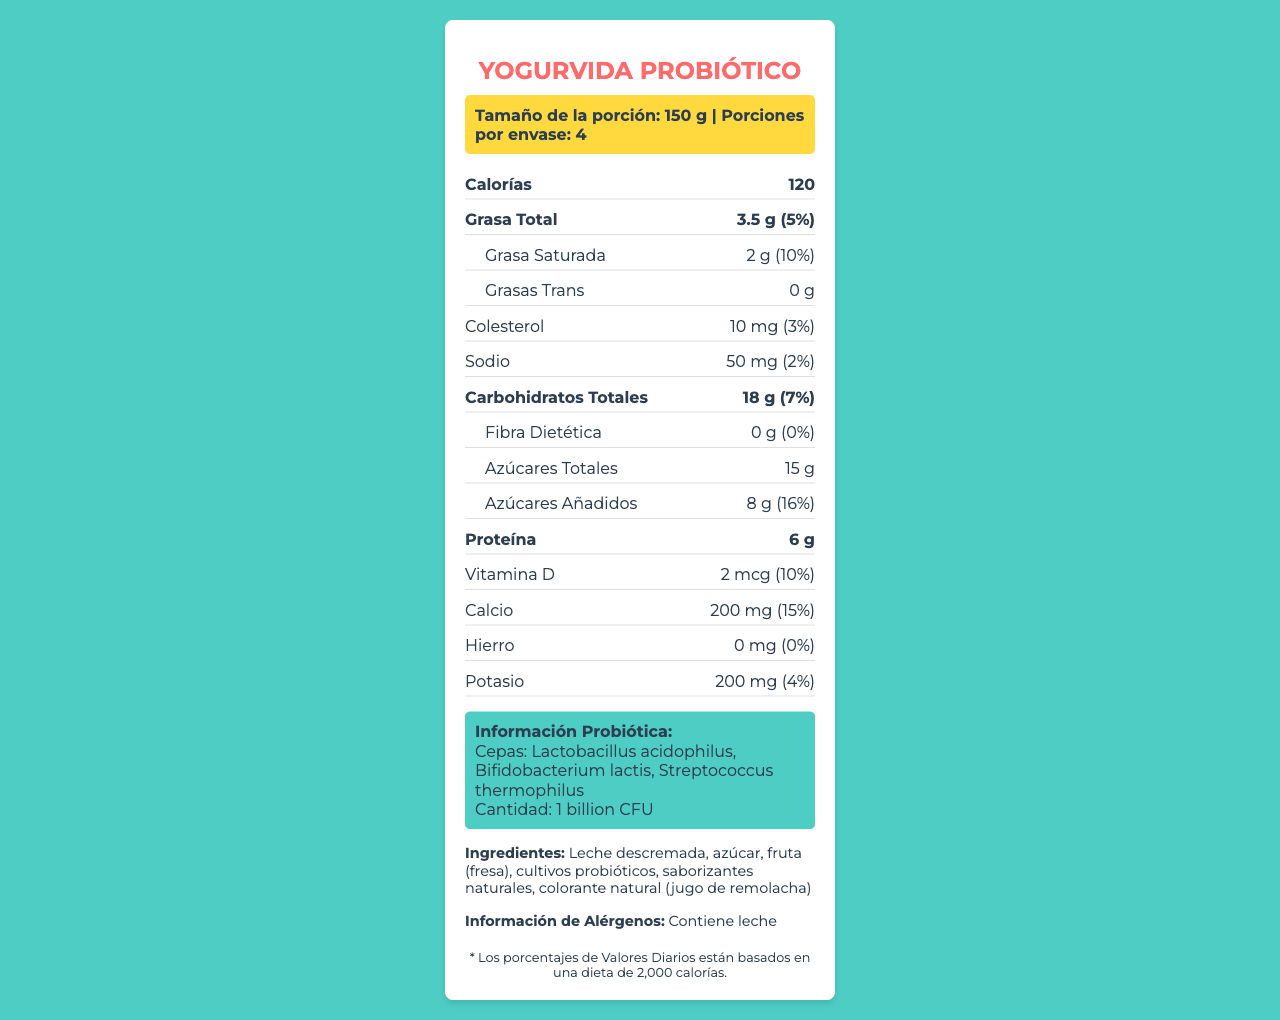¿Cuál es el tamaño de la porción? La información se encuentra en la sección de "Tamaño de la porción".
Answer: 150 g ¿Cuántas porciones hay por envase? La información se encuentra en la sección de "Porciones por envase".
Answer: 4 ¿Cuántas calorías tiene cada porción? La información se encuentra en la sección de "Calorías".
Answer: 120 ¿Qué cantidad de proteínas tiene el yogur? La información se encuentra en la sección de "Proteína".
Answer: 6 g ¿Qué porcentaje del valor diario de calcio proporciona una porción? La información se encuentra en la sección de "Calcio".
Answer: 15% ¿Qué ingredientes contiene el yogur? La información se encuentra en la sección de "Ingredientes".
Answer: Leche descremada, azúcar, fruta (fresa), cultivos probióticos, saborizantes naturales, colorante natural (jugo de remolacha) ¿Cuáles son las cepas probióticas presentes en este yogur? A. Lactobacillus acidophilus y Bifidobacterium breve B. Lactobacillus acidophilus y Streptococcus thermophilus C. Bifidobacterium lactis y Streptococcus thermophilus D. Lactobacillus acidophilus, Bifidobacterium lactis, y Streptococcus thermophilus La información se encuentra en la sección de "Información Probiótica".
Answer: D ¿Qué cantidad de vitamina D proporciona este yogur? A. 2 mcg B. 200 mg C. 50 mg D. 15 g La información se encuentra en la sección de "Vitamina D".
Answer: A ¿El yogur contiene grasas trans? La información se encuentra en la sección de "Grasas Trans" donde indica "0 g".
Answer: No ¿Este producto contiene alguna alergia conocida? La información se encuentra en la sección de "Información de Alérgenos".
Answer: Sí, contiene leche ¿Cómo describe el esquema de color usado en este documento? La información se encuentra en la sección de "colorScheme" en el diseño del documento.
Answer: Vibrante con colores primarios y secundarios. Principalmente, #FF6B6B, #4ECDC4, #FFD93D, #2C3E50 ¿Es posible saber la fecha de caducidad del yogur analizando esta etiqueta? El documento no proporciona ninguna fecha de caducidad o información sobre la duración del producto.
Answer: No hay suficiente información ¿Qué porcentaje de valor diario de azúcar añadido aporta una porción? La información se encuentra en la sección de "Azúcares Añadidos".
Answer: 16% Resuma el contenido principal de la etiqueta de datos nutricionales de YogurVida Probiótico. La etiqueta brinda una visión completa de los contenidos nutricionales y los beneficios del yogur probiótico, enfocándose en facilitar la interpretación a través de un diseño accesible.
Answer: La etiqueta muestra información nutricional del yogur probiótico YogurVida, que incluye el tamaño de la porción, calorías por porción, cantidad de nutrientes clave como grasas, proteínas, vitaminas y minerales. También proporciona detalles sobre ingredientes, información de alérgenos, cepas probióticas y su cantidad, así como características de diseño y usabilidad para el consumidor. 